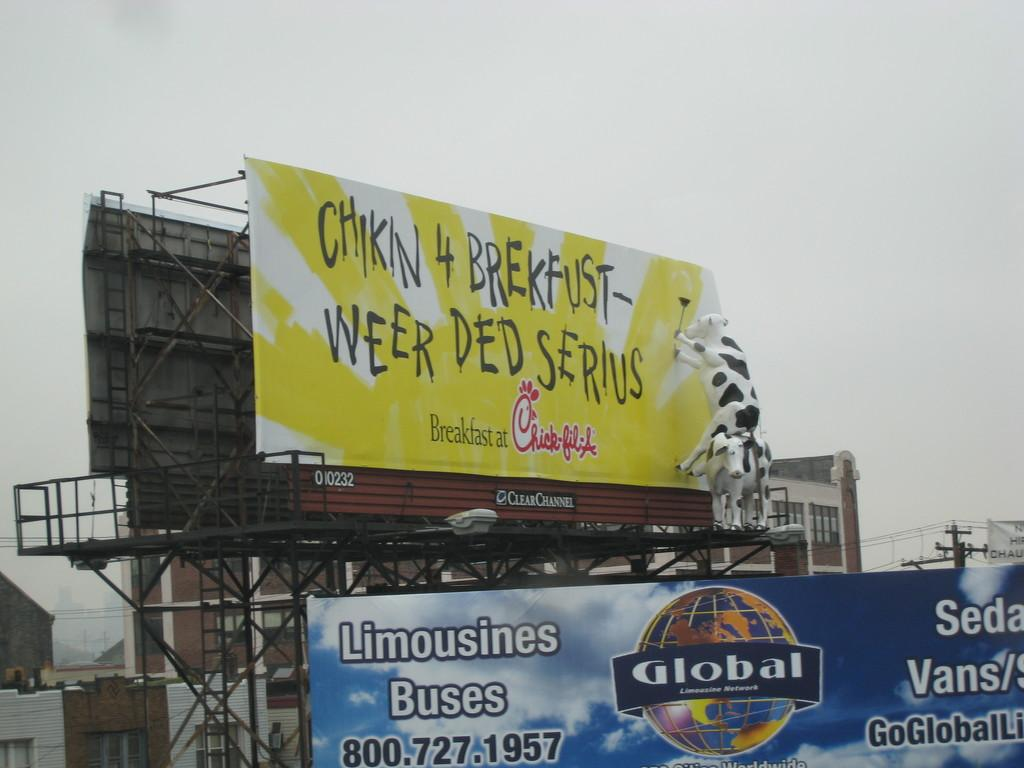<image>
Relay a brief, clear account of the picture shown. Chick-fil-a advertise on a billboard on the road for breakfast. 